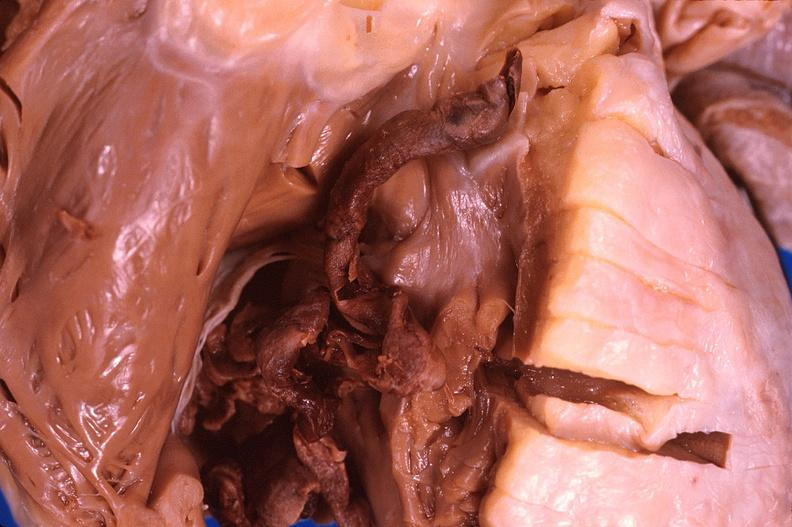where is this?
Answer the question using a single word or phrase. Heart 